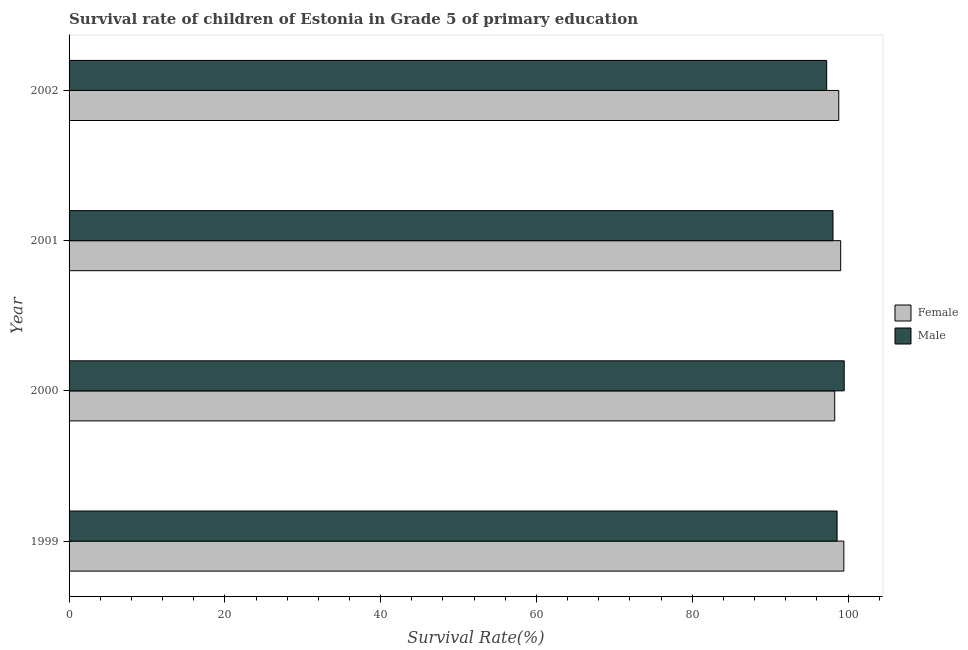Are the number of bars on each tick of the Y-axis equal?
Provide a short and direct response. Yes. How many bars are there on the 3rd tick from the top?
Give a very brief answer. 2. What is the label of the 4th group of bars from the top?
Make the answer very short. 1999. In how many cases, is the number of bars for a given year not equal to the number of legend labels?
Give a very brief answer. 0. What is the survival rate of female students in primary education in 2000?
Your answer should be very brief. 98.29. Across all years, what is the maximum survival rate of male students in primary education?
Ensure brevity in your answer.  99.51. Across all years, what is the minimum survival rate of male students in primary education?
Make the answer very short. 97.26. What is the total survival rate of female students in primary education in the graph?
Make the answer very short. 395.6. What is the difference between the survival rate of female students in primary education in 2000 and that in 2001?
Ensure brevity in your answer.  -0.77. What is the difference between the survival rate of female students in primary education in 2002 and the survival rate of male students in primary education in 2001?
Your response must be concise. 0.74. What is the average survival rate of female students in primary education per year?
Keep it short and to the point. 98.9. In the year 2000, what is the difference between the survival rate of male students in primary education and survival rate of female students in primary education?
Provide a short and direct response. 1.22. In how many years, is the survival rate of male students in primary education greater than 28 %?
Provide a succinct answer. 4. What is the difference between the highest and the second highest survival rate of male students in primary education?
Keep it short and to the point. 0.92. What is the difference between the highest and the lowest survival rate of male students in primary education?
Your response must be concise. 2.25. Is the sum of the survival rate of male students in primary education in 1999 and 2001 greater than the maximum survival rate of female students in primary education across all years?
Provide a succinct answer. Yes. Are all the bars in the graph horizontal?
Your answer should be compact. Yes. Does the graph contain grids?
Your answer should be very brief. No. What is the title of the graph?
Your answer should be compact. Survival rate of children of Estonia in Grade 5 of primary education. What is the label or title of the X-axis?
Ensure brevity in your answer.  Survival Rate(%). What is the Survival Rate(%) of Female in 1999?
Make the answer very short. 99.46. What is the Survival Rate(%) in Male in 1999?
Your answer should be very brief. 98.59. What is the Survival Rate(%) of Female in 2000?
Your response must be concise. 98.29. What is the Survival Rate(%) in Male in 2000?
Give a very brief answer. 99.51. What is the Survival Rate(%) of Female in 2001?
Provide a succinct answer. 99.05. What is the Survival Rate(%) in Male in 2001?
Offer a terse response. 98.07. What is the Survival Rate(%) of Female in 2002?
Keep it short and to the point. 98.81. What is the Survival Rate(%) in Male in 2002?
Provide a succinct answer. 97.26. Across all years, what is the maximum Survival Rate(%) of Female?
Ensure brevity in your answer.  99.46. Across all years, what is the maximum Survival Rate(%) of Male?
Your answer should be very brief. 99.51. Across all years, what is the minimum Survival Rate(%) of Female?
Offer a very short reply. 98.29. Across all years, what is the minimum Survival Rate(%) in Male?
Offer a terse response. 97.26. What is the total Survival Rate(%) in Female in the graph?
Give a very brief answer. 395.6. What is the total Survival Rate(%) of Male in the graph?
Ensure brevity in your answer.  393.42. What is the difference between the Survival Rate(%) of Female in 1999 and that in 2000?
Your answer should be compact. 1.17. What is the difference between the Survival Rate(%) of Male in 1999 and that in 2000?
Keep it short and to the point. -0.92. What is the difference between the Survival Rate(%) in Female in 1999 and that in 2001?
Give a very brief answer. 0.41. What is the difference between the Survival Rate(%) in Male in 1999 and that in 2001?
Ensure brevity in your answer.  0.52. What is the difference between the Survival Rate(%) in Female in 1999 and that in 2002?
Your response must be concise. 0.65. What is the difference between the Survival Rate(%) in Male in 1999 and that in 2002?
Your answer should be compact. 1.33. What is the difference between the Survival Rate(%) of Female in 2000 and that in 2001?
Offer a very short reply. -0.76. What is the difference between the Survival Rate(%) of Male in 2000 and that in 2001?
Your answer should be very brief. 1.44. What is the difference between the Survival Rate(%) of Female in 2000 and that in 2002?
Ensure brevity in your answer.  -0.52. What is the difference between the Survival Rate(%) in Male in 2000 and that in 2002?
Provide a succinct answer. 2.25. What is the difference between the Survival Rate(%) in Female in 2001 and that in 2002?
Make the answer very short. 0.24. What is the difference between the Survival Rate(%) in Male in 2001 and that in 2002?
Your answer should be very brief. 0.81. What is the difference between the Survival Rate(%) of Female in 1999 and the Survival Rate(%) of Male in 2000?
Offer a terse response. -0.05. What is the difference between the Survival Rate(%) in Female in 1999 and the Survival Rate(%) in Male in 2001?
Provide a succinct answer. 1.39. What is the difference between the Survival Rate(%) of Female in 1999 and the Survival Rate(%) of Male in 2002?
Offer a very short reply. 2.2. What is the difference between the Survival Rate(%) in Female in 2000 and the Survival Rate(%) in Male in 2001?
Ensure brevity in your answer.  0.22. What is the difference between the Survival Rate(%) of Female in 2000 and the Survival Rate(%) of Male in 2002?
Provide a short and direct response. 1.03. What is the difference between the Survival Rate(%) in Female in 2001 and the Survival Rate(%) in Male in 2002?
Provide a short and direct response. 1.79. What is the average Survival Rate(%) in Female per year?
Make the answer very short. 98.9. What is the average Survival Rate(%) in Male per year?
Give a very brief answer. 98.35. In the year 1999, what is the difference between the Survival Rate(%) in Female and Survival Rate(%) in Male?
Your answer should be compact. 0.87. In the year 2000, what is the difference between the Survival Rate(%) of Female and Survival Rate(%) of Male?
Your answer should be compact. -1.22. In the year 2001, what is the difference between the Survival Rate(%) of Female and Survival Rate(%) of Male?
Give a very brief answer. 0.98. In the year 2002, what is the difference between the Survival Rate(%) of Female and Survival Rate(%) of Male?
Keep it short and to the point. 1.55. What is the ratio of the Survival Rate(%) in Female in 1999 to that in 2000?
Provide a short and direct response. 1.01. What is the ratio of the Survival Rate(%) in Female in 1999 to that in 2002?
Make the answer very short. 1.01. What is the ratio of the Survival Rate(%) in Male in 1999 to that in 2002?
Give a very brief answer. 1.01. What is the ratio of the Survival Rate(%) of Male in 2000 to that in 2001?
Ensure brevity in your answer.  1.01. What is the ratio of the Survival Rate(%) in Male in 2000 to that in 2002?
Give a very brief answer. 1.02. What is the ratio of the Survival Rate(%) of Female in 2001 to that in 2002?
Make the answer very short. 1. What is the ratio of the Survival Rate(%) in Male in 2001 to that in 2002?
Provide a succinct answer. 1.01. What is the difference between the highest and the second highest Survival Rate(%) in Female?
Your answer should be very brief. 0.41. What is the difference between the highest and the second highest Survival Rate(%) of Male?
Ensure brevity in your answer.  0.92. What is the difference between the highest and the lowest Survival Rate(%) of Female?
Ensure brevity in your answer.  1.17. What is the difference between the highest and the lowest Survival Rate(%) of Male?
Your answer should be very brief. 2.25. 